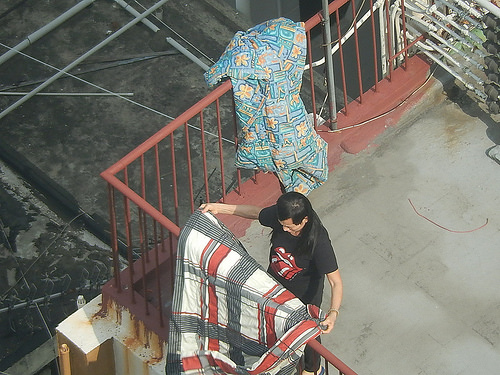<image>
Is there a blanket on the fence? Yes. Looking at the image, I can see the blanket is positioned on top of the fence, with the fence providing support. Is there a blanket on the man? No. The blanket is not positioned on the man. They may be near each other, but the blanket is not supported by or resting on top of the man. 